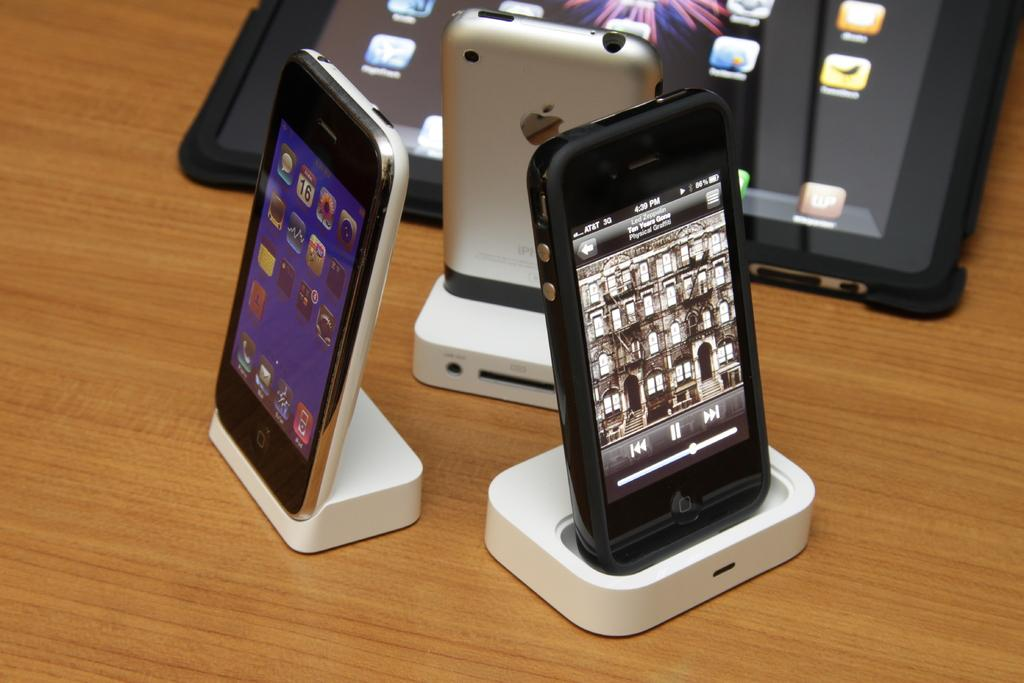<image>
Relay a brief, clear account of the picture shown. Some Apple iPhone in docking stations, one showing the time as 4:39 PM. 